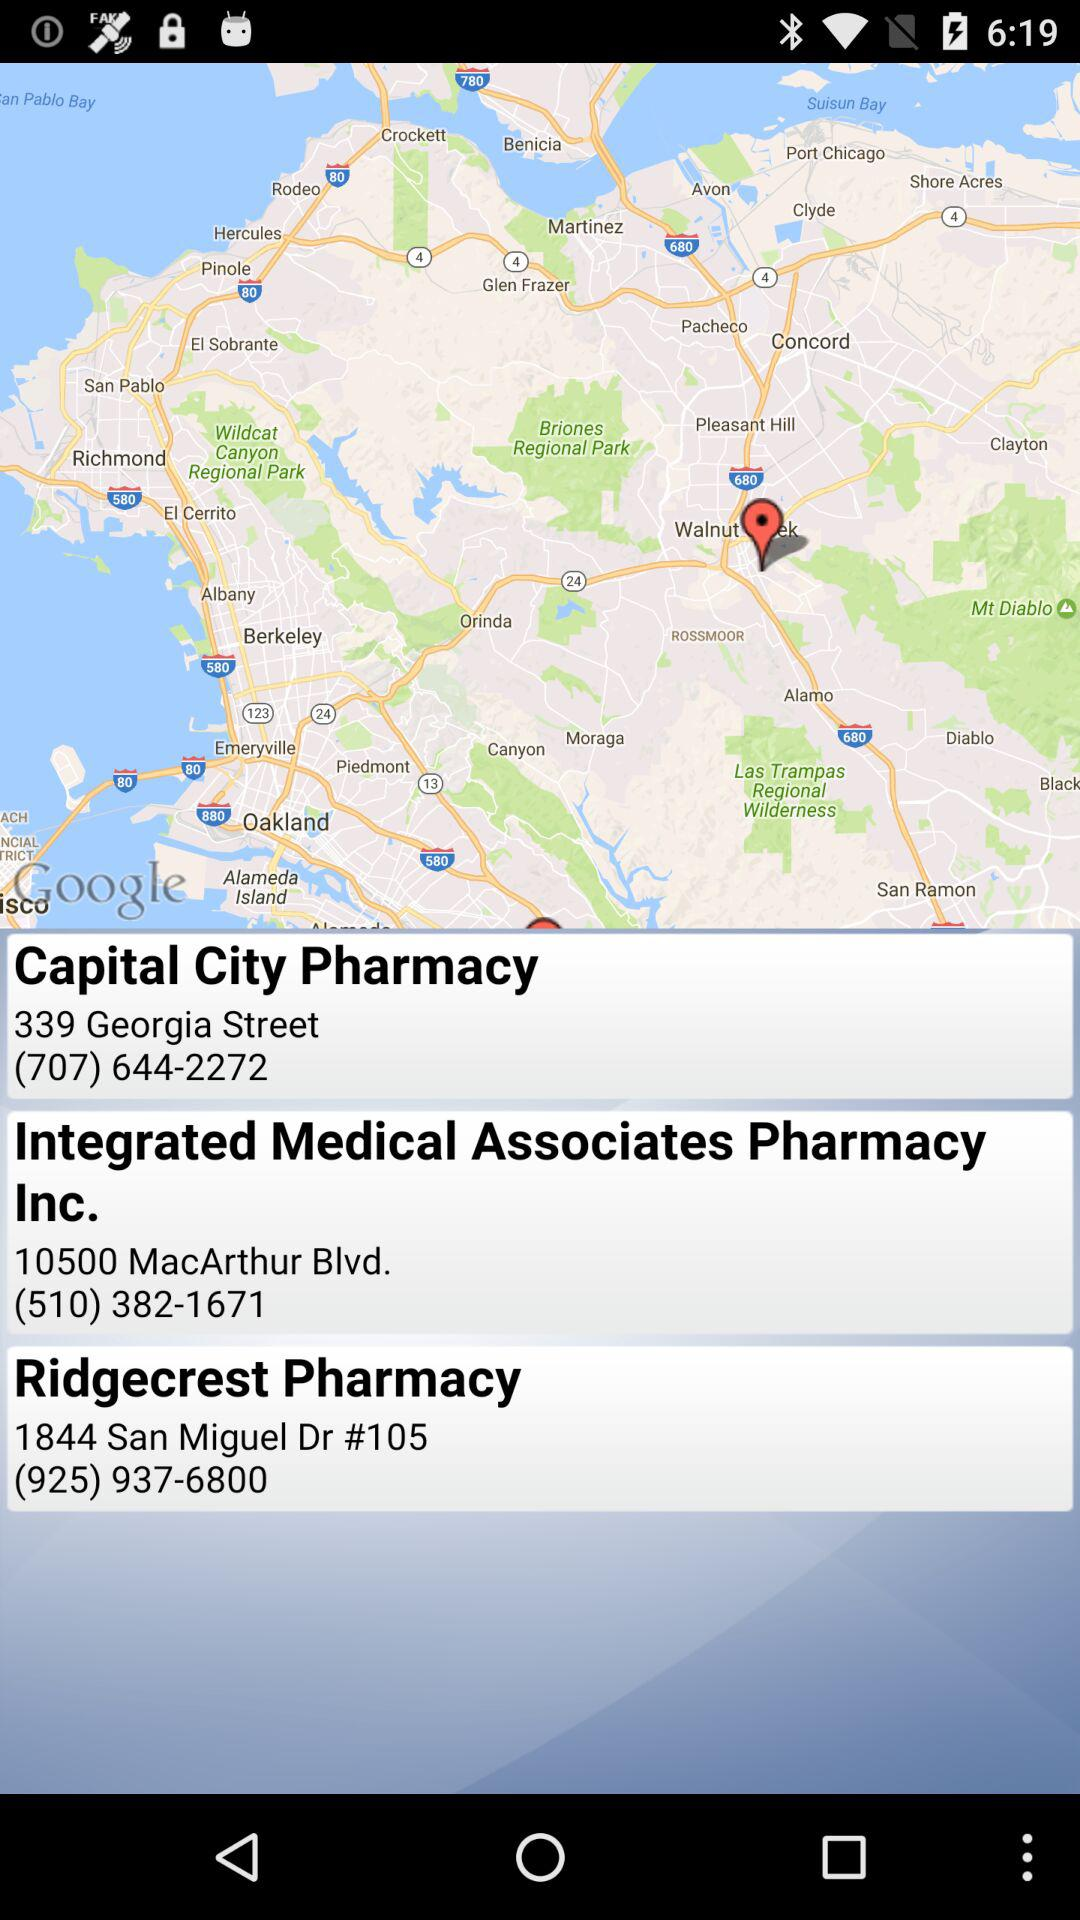What is the address of Capital City Pharmacy? The address is 339 Georgia Street, (707) 644-2272. 